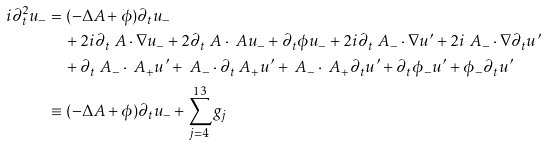<formula> <loc_0><loc_0><loc_500><loc_500>i \partial _ { t } ^ { 2 } u _ { - } & = ( - \Delta A + \phi ) \partial _ { t } u _ { - } \\ & \quad + 2 i \partial _ { t } \ A \cdot \nabla u _ { - } + 2 \partial _ { t } \ A \cdot \ A u _ { - } + \partial _ { t } \phi u _ { - } + 2 i \partial _ { t } \ A _ { - } \cdot \nabla u ^ { \prime } + 2 i \ A _ { - } \cdot \nabla \partial _ { t } u ^ { \prime } \\ & \quad + \partial _ { t } \ A _ { - } \cdot \ A _ { + } u ^ { \prime } + \ A _ { - } \cdot \partial _ { t } \ A _ { + } u ^ { \prime } + \ A _ { - } \cdot \ A _ { + } \partial _ { t } u ^ { \prime } + \partial _ { t } \phi _ { - } u ^ { \prime } + \phi _ { - } \partial _ { t } u ^ { \prime } \\ & \equiv ( - \Delta A + \phi ) \partial _ { t } u _ { - } + \sum _ { j = 4 } ^ { 1 3 } g _ { j }</formula> 